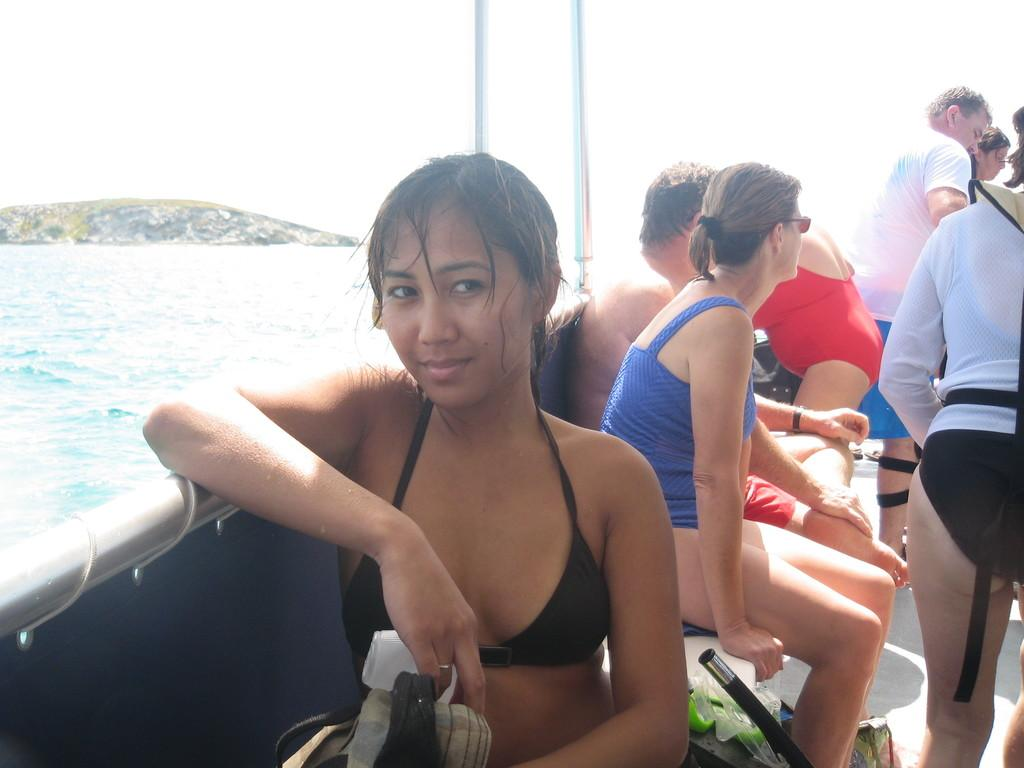What is the main subject of the picture? The main subject of the picture is a ship. Are there any people on the ship? Yes, there is a group of people on the ship. What is the ship's position in relation to the water? The ship is floating on the water surface. What can be seen in the background of the image? There is a small rock surface in the background of the image. What is the chance of thunder occurring in the image? There is no mention of thunder or weather conditions in the image, so it's not possible to determine the chance of thunder occurring. 